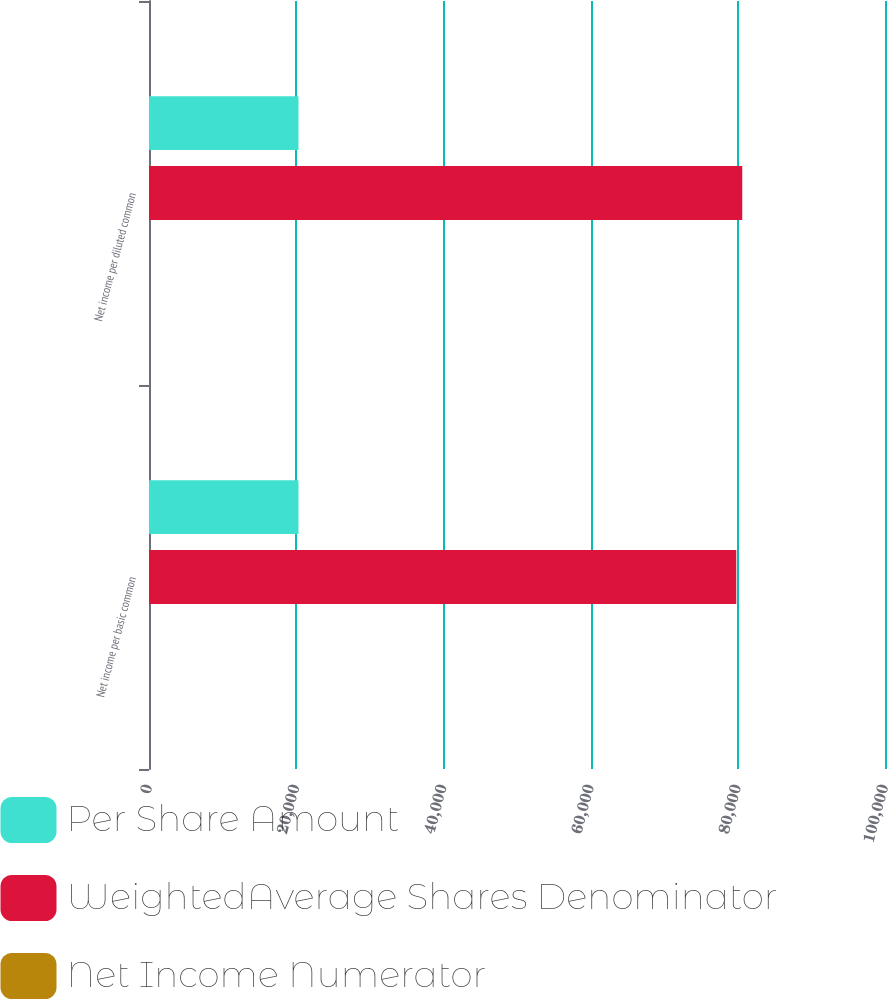Convert chart. <chart><loc_0><loc_0><loc_500><loc_500><stacked_bar_chart><ecel><fcel>Net income per basic common<fcel>Net income per diluted common<nl><fcel>Per Share Amount<fcel>20311<fcel>20311<nl><fcel>WeightedAverage Shares Denominator<fcel>79793<fcel>80604<nl><fcel>Net Income Numerator<fcel>0.25<fcel>0.25<nl></chart> 